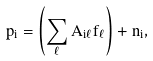Convert formula to latex. <formula><loc_0><loc_0><loc_500><loc_500>p _ { i } = \left ( \sum _ { \ell } A _ { i \ell } f _ { \ell } \right ) + n _ { i } ,</formula> 